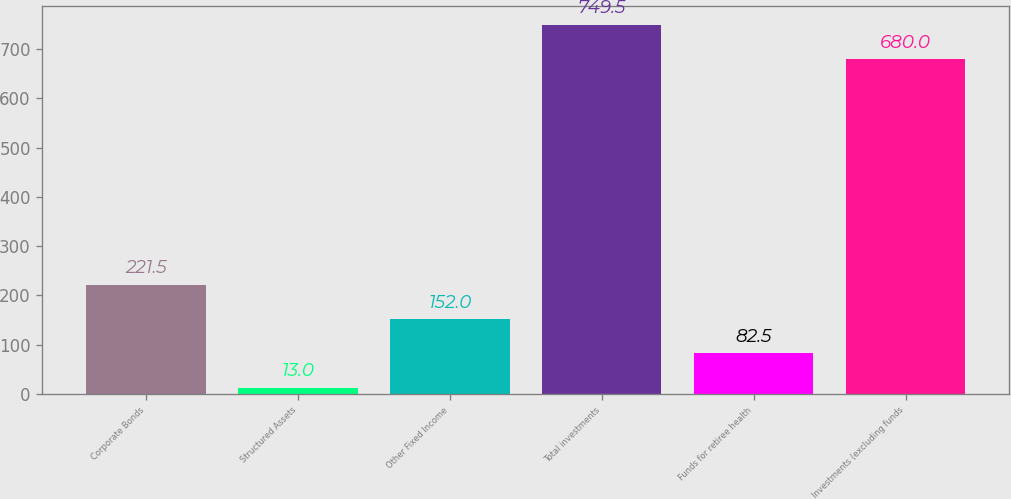Convert chart to OTSL. <chart><loc_0><loc_0><loc_500><loc_500><bar_chart><fcel>Corporate Bonds<fcel>Structured Assets<fcel>Other Fixed Income<fcel>Total investments<fcel>Funds for retiree health<fcel>Investments (excluding funds<nl><fcel>221.5<fcel>13<fcel>152<fcel>749.5<fcel>82.5<fcel>680<nl></chart> 